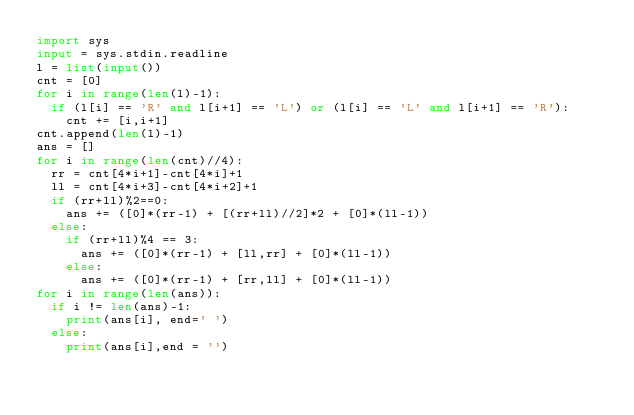<code> <loc_0><loc_0><loc_500><loc_500><_Python_>import sys
input = sys.stdin.readline
l = list(input())
cnt = [0]
for i in range(len(l)-1):
  if (l[i] == 'R' and l[i+1] == 'L') or (l[i] == 'L' and l[i+1] == 'R'):
    cnt += [i,i+1]
cnt.append(len(l)-1)
ans = []
for i in range(len(cnt)//4):
  rr = cnt[4*i+1]-cnt[4*i]+1
  ll = cnt[4*i+3]-cnt[4*i+2]+1
  if (rr+ll)%2==0:
    ans += ([0]*(rr-1) + [(rr+ll)//2]*2 + [0]*(ll-1))
  else:
    if (rr+ll)%4 == 3:
      ans += ([0]*(rr-1) + [ll,rr] + [0]*(ll-1))
    else:
      ans += ([0]*(rr-1) + [rr,ll] + [0]*(ll-1))
for i in range(len(ans)):
  if i != len(ans)-1:
    print(ans[i], end=' ')
  else:
    print(ans[i],end = '')</code> 